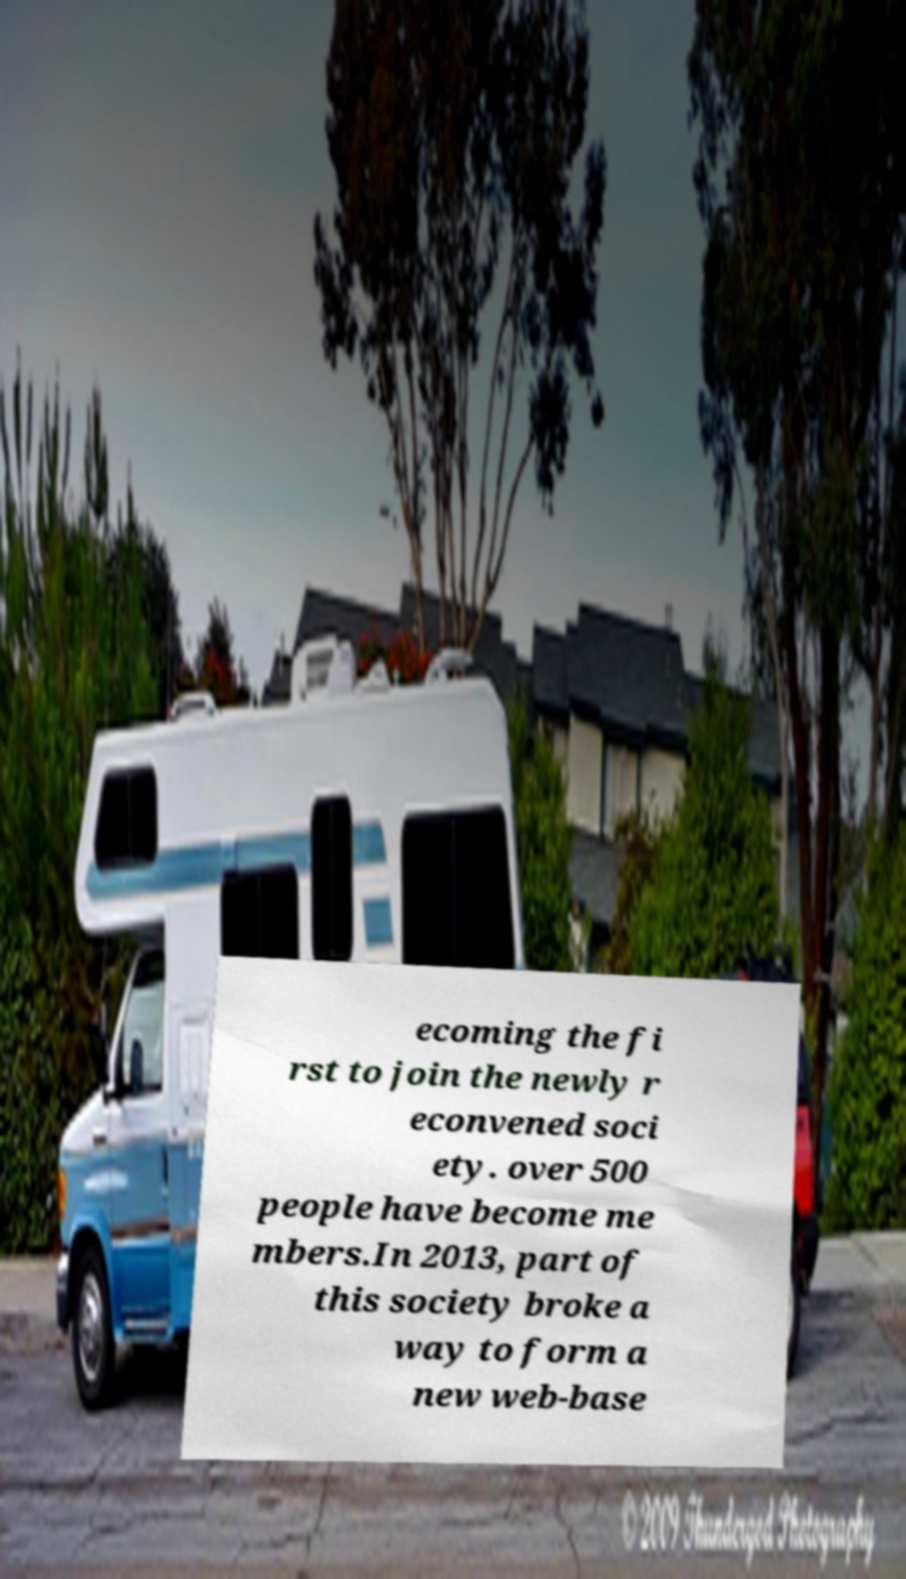Can you read and provide the text displayed in the image?This photo seems to have some interesting text. Can you extract and type it out for me? ecoming the fi rst to join the newly r econvened soci ety. over 500 people have become me mbers.In 2013, part of this society broke a way to form a new web-base 